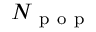Convert formula to latex. <formula><loc_0><loc_0><loc_500><loc_500>N _ { p o p }</formula> 